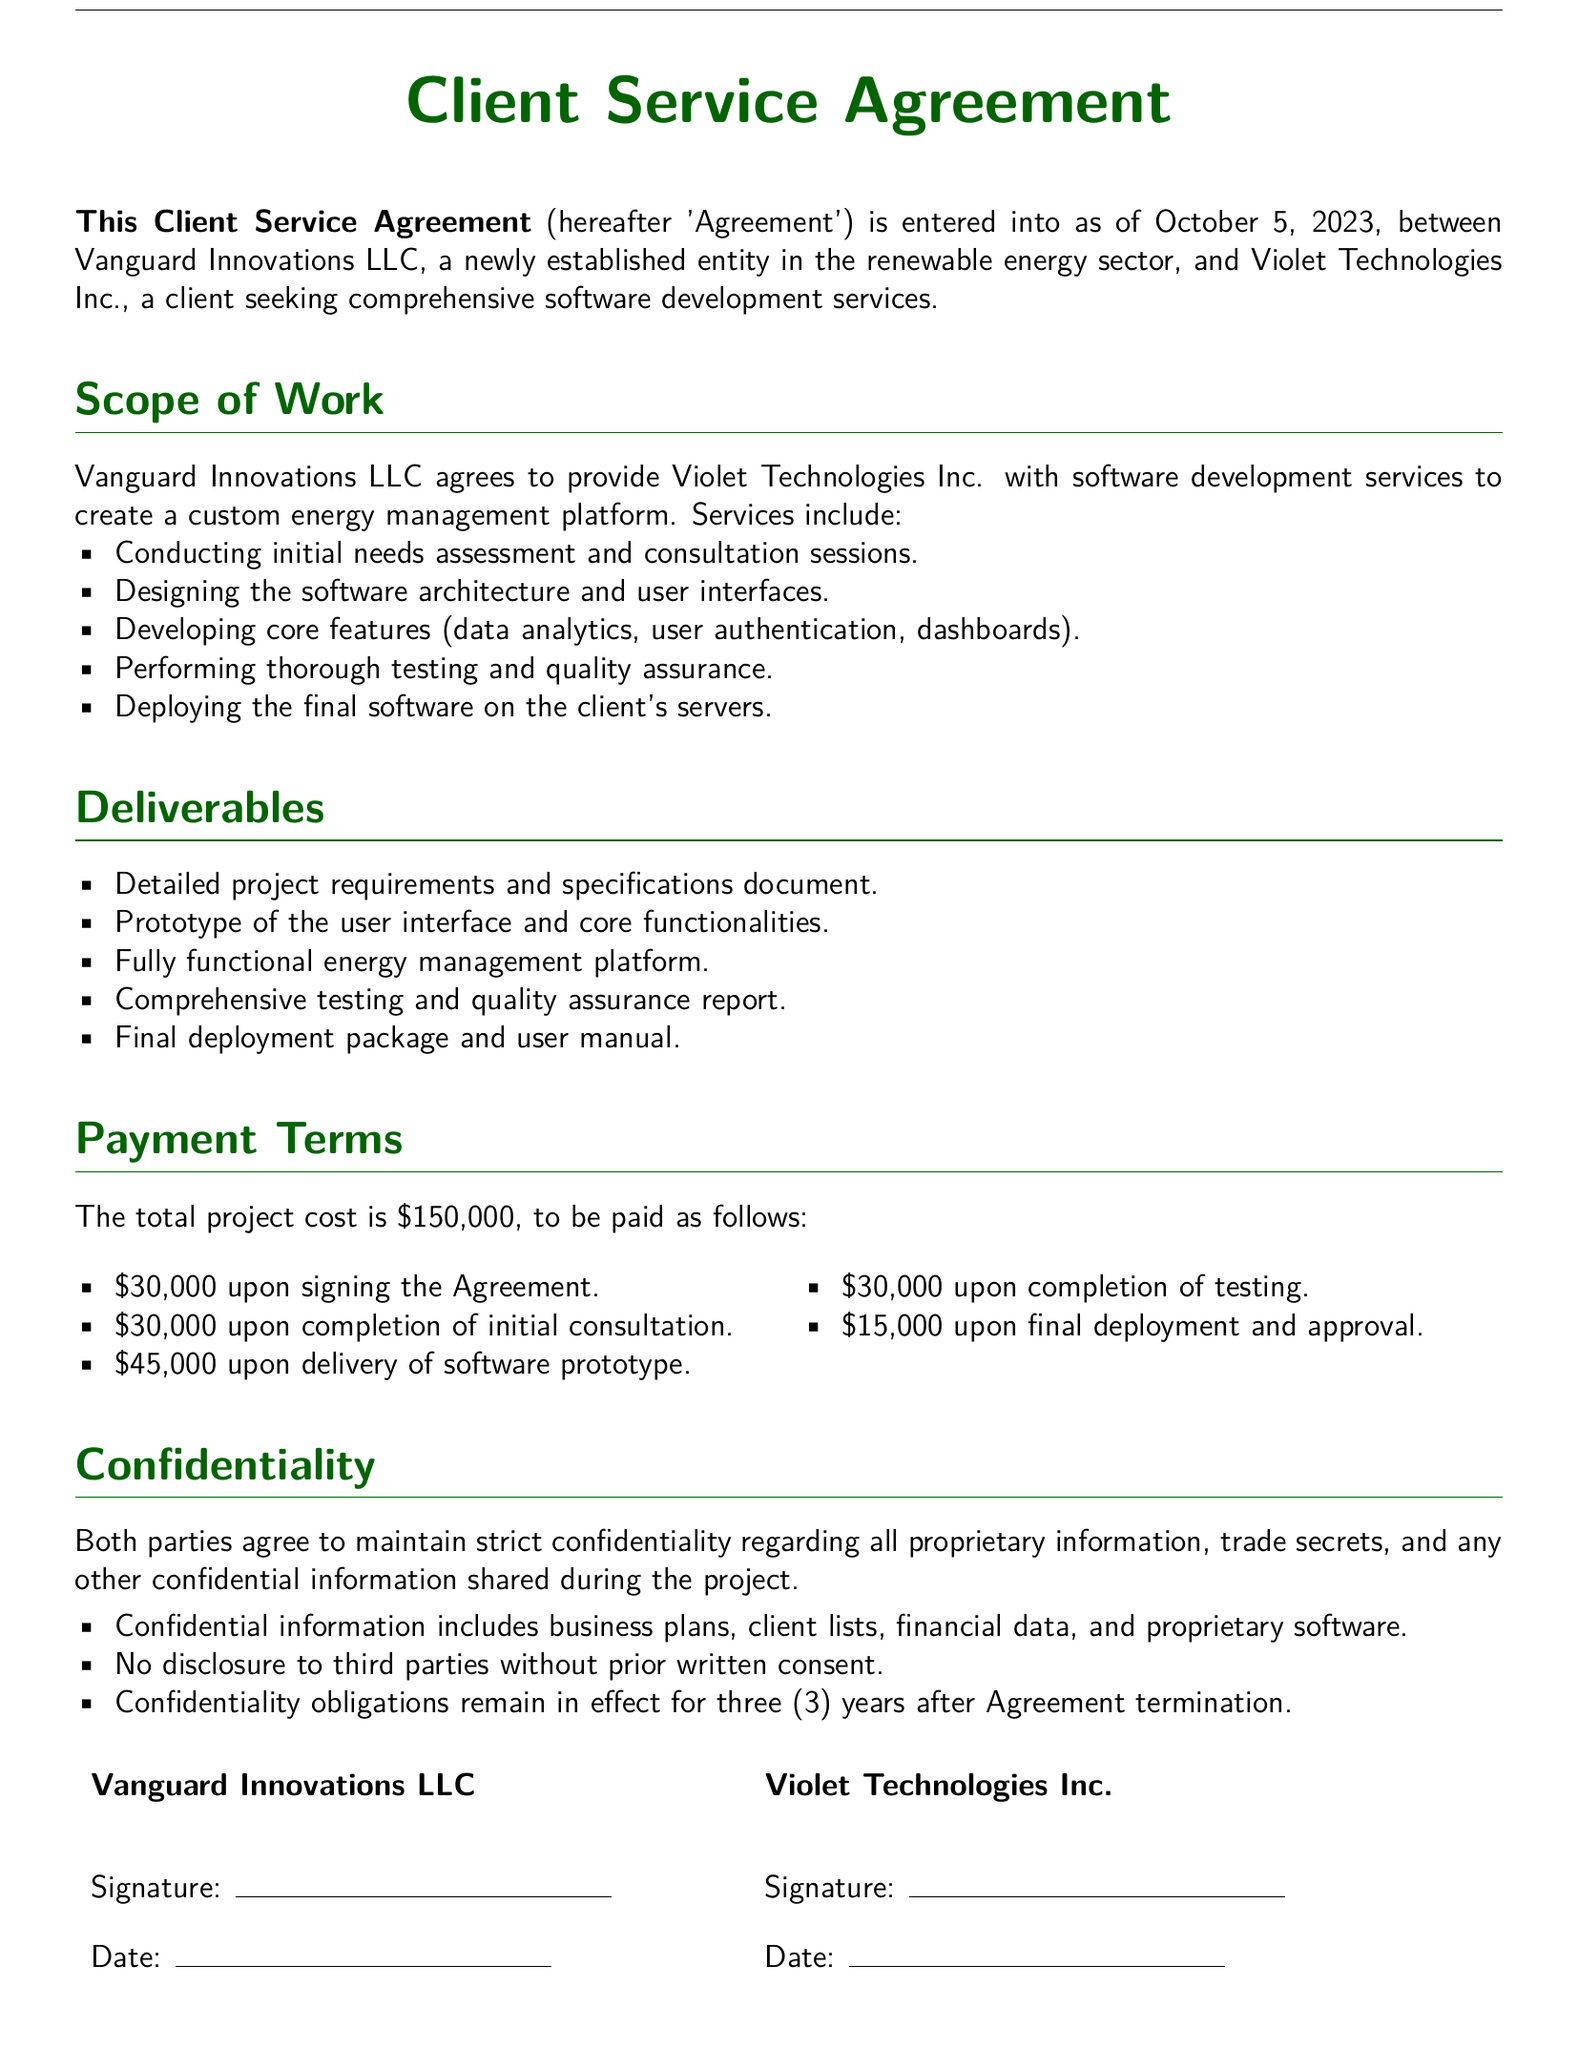What is the total project cost? The total project cost is explicitly stated in the document as $150,000.
Answer: $150,000 Who are the parties involved in this Agreement? The document specifies the two parties as Vanguard Innovations LLC and Violet Technologies Inc.
Answer: Vanguard Innovations LLC and Violet Technologies Inc When was the Agreement entered into? The date the Agreement was entered into is mentioned at the beginning of the document.
Answer: October 5, 2023 What is the first payment amount due upon signing the Agreement? The document clearly outlines the payment terms, stating the first payment upon signing is $30,000.
Answer: $30,000 What is one of the confidentiality obligations mentioned in the document? The document states that confidential information includes business plans, client lists, financial data, and proprietary software.
Answer: No disclosure to third parties without prior written consent What needs to be delivered upon completion of the initial consultation? According to the Deliverables section, the completion of initial consultation results in the delivery of a detailed project requirements and specifications document.
Answer: Detailed project requirements and specifications document What is the confidentiality period after Agreement termination? The document specifies the duration for which confidentiality obligations remain in effect after the termination of the Agreement.
Answer: Three (3) years What is included in the scope of work? The scope of work includes several services, primarily focusing on software development services for an energy management platform.
Answer: Software development services to create a custom energy management platform 